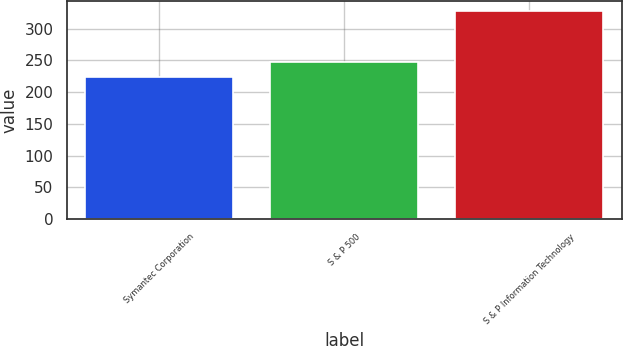<chart> <loc_0><loc_0><loc_500><loc_500><bar_chart><fcel>Symantec Corporation<fcel>S & P 500<fcel>S & P Information Technology<nl><fcel>223.91<fcel>247.13<fcel>327.9<nl></chart> 